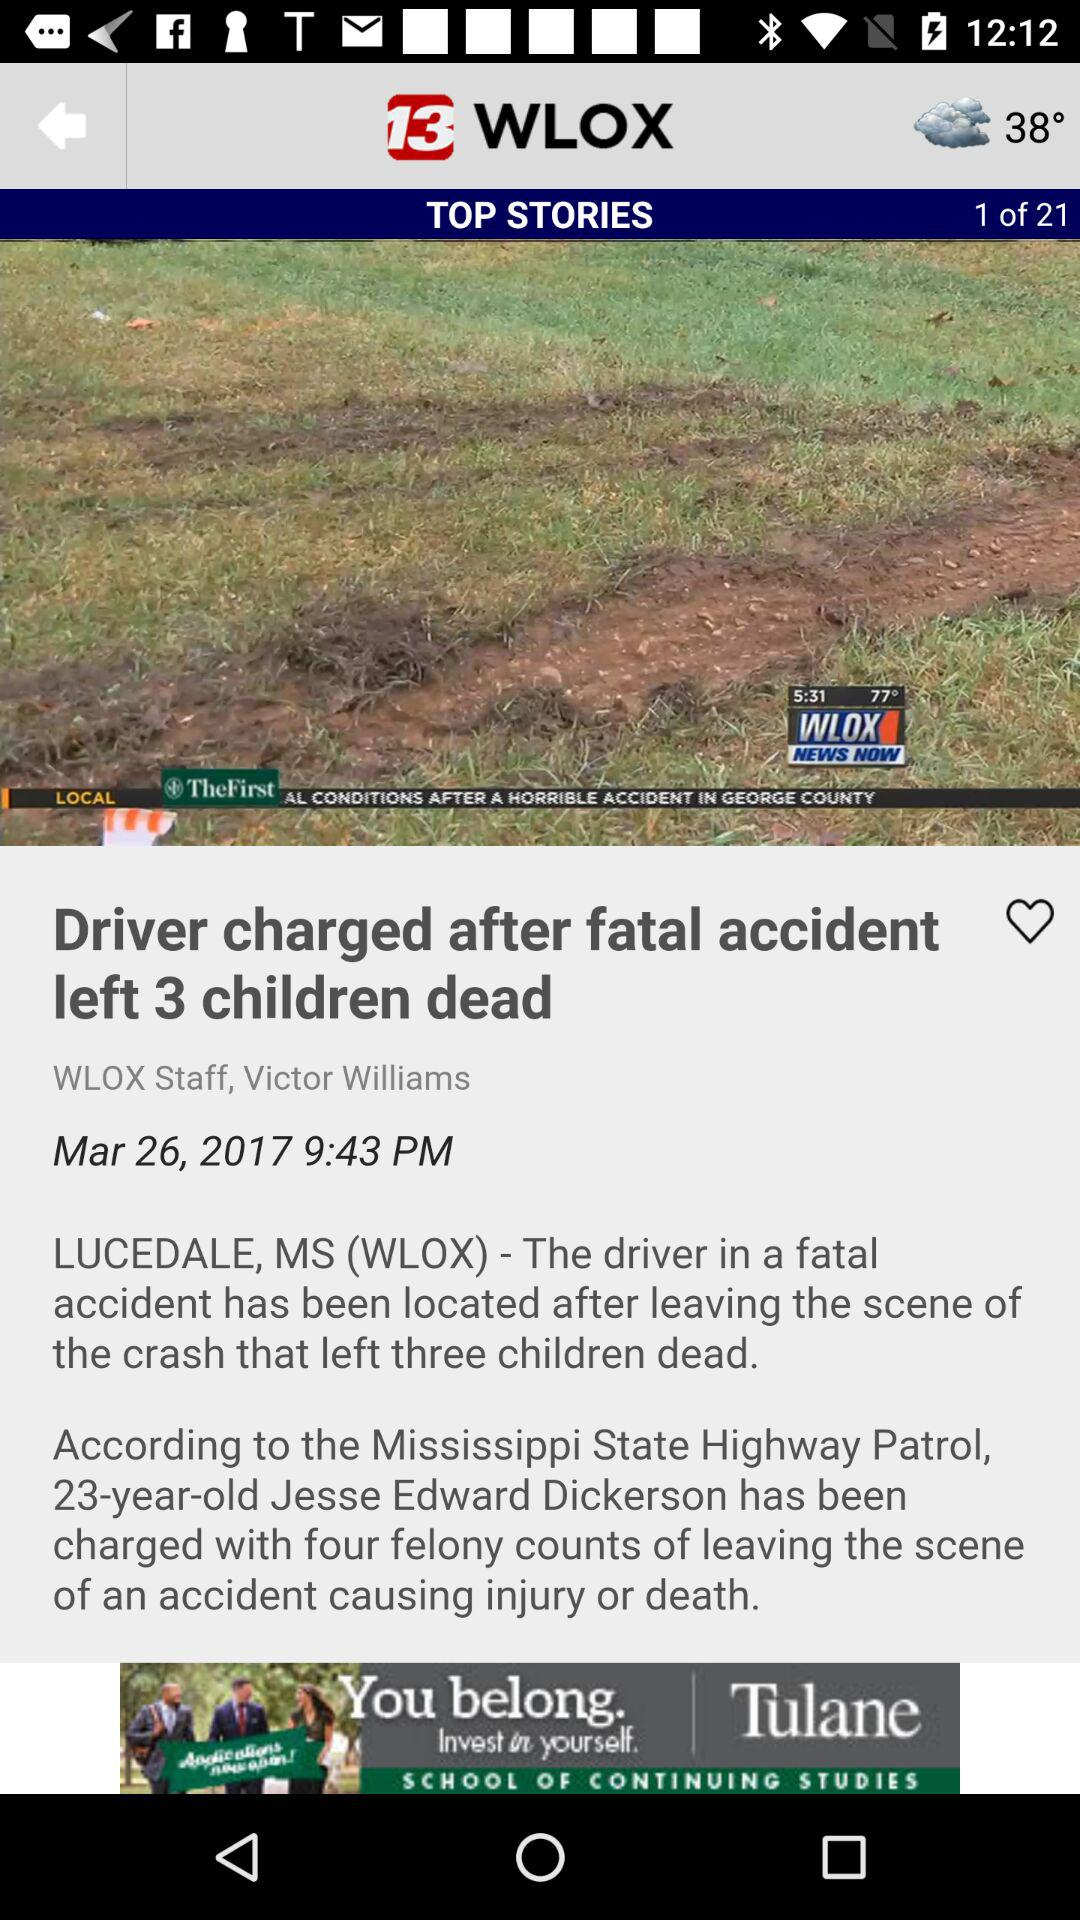What's the publication date of the news article "Driver charged after fatal accident left 3 children dead"? The publication date of the news article "Driver charged after fatal accident left 3 children dead" is March 26, 2017. 